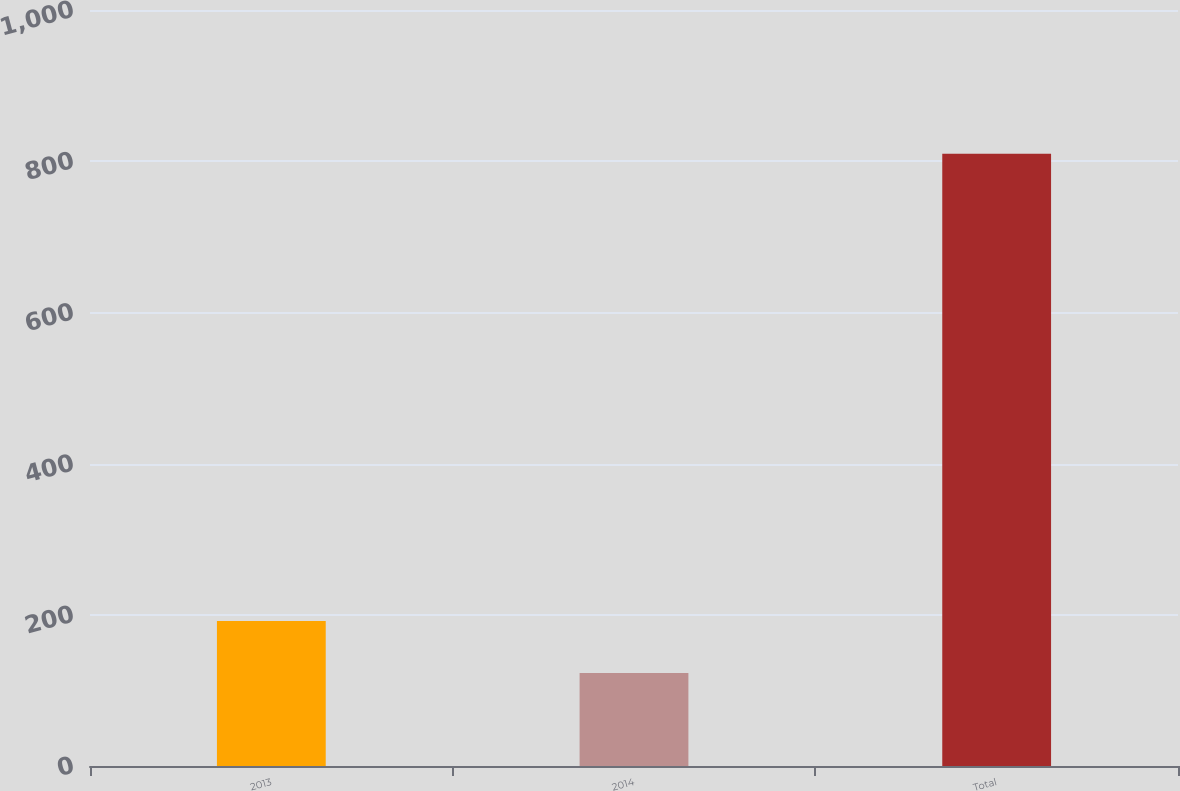Convert chart to OTSL. <chart><loc_0><loc_0><loc_500><loc_500><bar_chart><fcel>2013<fcel>2014<fcel>Total<nl><fcel>191.7<fcel>123<fcel>810<nl></chart> 